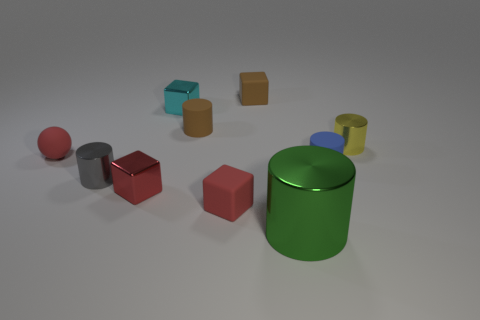Subtract all brown blocks. How many blocks are left? 3 Subtract all tiny gray cylinders. How many cylinders are left? 4 Subtract 1 blocks. How many blocks are left? 3 Subtract all yellow cylinders. Subtract all yellow balls. How many cylinders are left? 4 Subtract all balls. How many objects are left? 9 Add 3 red things. How many red things exist? 6 Subtract 0 green blocks. How many objects are left? 10 Subtract all tiny objects. Subtract all red balls. How many objects are left? 0 Add 9 yellow cylinders. How many yellow cylinders are left? 10 